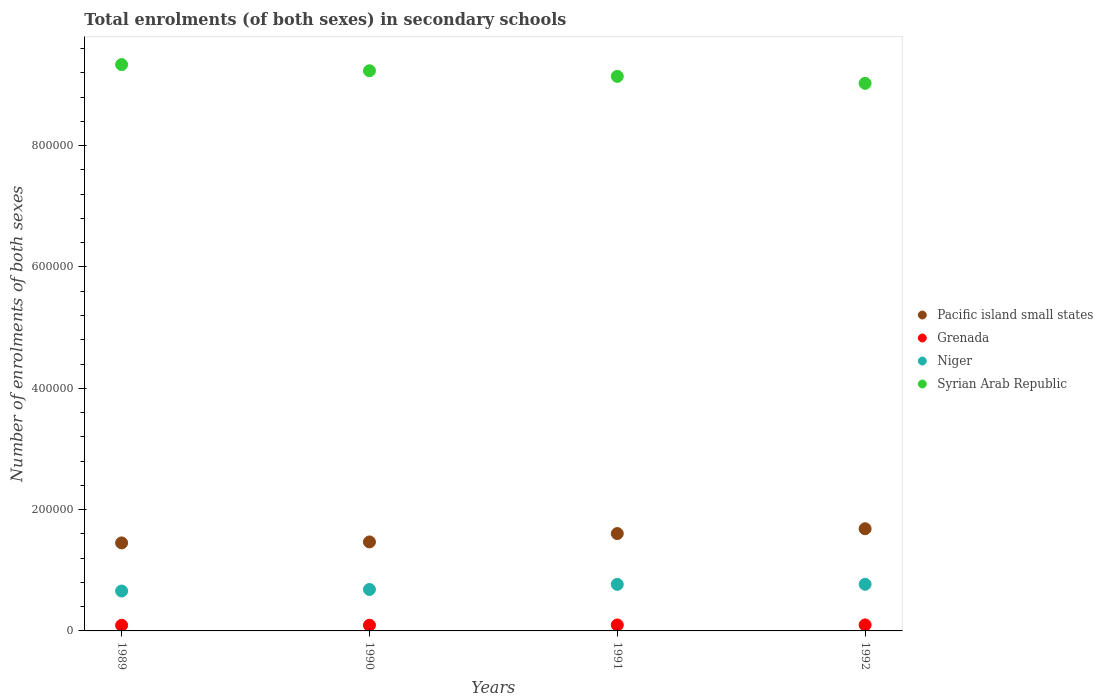Is the number of dotlines equal to the number of legend labels?
Your response must be concise. Yes. What is the number of enrolments in secondary schools in Niger in 1992?
Make the answer very short. 7.69e+04. Across all years, what is the maximum number of enrolments in secondary schools in Niger?
Ensure brevity in your answer.  7.69e+04. Across all years, what is the minimum number of enrolments in secondary schools in Niger?
Ensure brevity in your answer.  6.58e+04. In which year was the number of enrolments in secondary schools in Niger maximum?
Your answer should be compact. 1992. What is the total number of enrolments in secondary schools in Syrian Arab Republic in the graph?
Ensure brevity in your answer.  3.67e+06. What is the difference between the number of enrolments in secondary schools in Grenada in 1990 and that in 1991?
Offer a very short reply. -370. What is the difference between the number of enrolments in secondary schools in Grenada in 1992 and the number of enrolments in secondary schools in Syrian Arab Republic in 1990?
Give a very brief answer. -9.14e+05. What is the average number of enrolments in secondary schools in Grenada per year?
Provide a short and direct response. 9599.25. In the year 1992, what is the difference between the number of enrolments in secondary schools in Grenada and number of enrolments in secondary schools in Syrian Arab Republic?
Keep it short and to the point. -8.93e+05. What is the ratio of the number of enrolments in secondary schools in Pacific island small states in 1990 to that in 1991?
Provide a short and direct response. 0.91. What is the difference between the highest and the second highest number of enrolments in secondary schools in Syrian Arab Republic?
Offer a very short reply. 1.01e+04. What is the difference between the highest and the lowest number of enrolments in secondary schools in Syrian Arab Republic?
Your answer should be compact. 3.08e+04. Does the number of enrolments in secondary schools in Pacific island small states monotonically increase over the years?
Your answer should be very brief. Yes. Is the number of enrolments in secondary schools in Pacific island small states strictly less than the number of enrolments in secondary schools in Grenada over the years?
Your answer should be compact. No. How many dotlines are there?
Provide a succinct answer. 4. How many years are there in the graph?
Keep it short and to the point. 4. Are the values on the major ticks of Y-axis written in scientific E-notation?
Ensure brevity in your answer.  No. Does the graph contain grids?
Give a very brief answer. No. How many legend labels are there?
Your answer should be compact. 4. What is the title of the graph?
Offer a terse response. Total enrolments (of both sexes) in secondary schools. What is the label or title of the Y-axis?
Make the answer very short. Number of enrolments of both sexes. What is the Number of enrolments of both sexes of Pacific island small states in 1989?
Your answer should be compact. 1.45e+05. What is the Number of enrolments of both sexes in Grenada in 1989?
Give a very brief answer. 9319. What is the Number of enrolments of both sexes in Niger in 1989?
Provide a short and direct response. 6.58e+04. What is the Number of enrolments of both sexes of Syrian Arab Republic in 1989?
Ensure brevity in your answer.  9.34e+05. What is the Number of enrolments of both sexes of Pacific island small states in 1990?
Offer a very short reply. 1.47e+05. What is the Number of enrolments of both sexes of Grenada in 1990?
Your answer should be compact. 9406. What is the Number of enrolments of both sexes of Niger in 1990?
Provide a succinct answer. 6.84e+04. What is the Number of enrolments of both sexes of Syrian Arab Republic in 1990?
Offer a very short reply. 9.24e+05. What is the Number of enrolments of both sexes in Pacific island small states in 1991?
Provide a succinct answer. 1.61e+05. What is the Number of enrolments of both sexes in Grenada in 1991?
Ensure brevity in your answer.  9776. What is the Number of enrolments of both sexes in Niger in 1991?
Keep it short and to the point. 7.68e+04. What is the Number of enrolments of both sexes of Syrian Arab Republic in 1991?
Offer a terse response. 9.14e+05. What is the Number of enrolments of both sexes of Pacific island small states in 1992?
Provide a short and direct response. 1.68e+05. What is the Number of enrolments of both sexes of Grenada in 1992?
Offer a terse response. 9896. What is the Number of enrolments of both sexes of Niger in 1992?
Provide a short and direct response. 7.69e+04. What is the Number of enrolments of both sexes in Syrian Arab Republic in 1992?
Give a very brief answer. 9.03e+05. Across all years, what is the maximum Number of enrolments of both sexes of Pacific island small states?
Make the answer very short. 1.68e+05. Across all years, what is the maximum Number of enrolments of both sexes in Grenada?
Make the answer very short. 9896. Across all years, what is the maximum Number of enrolments of both sexes of Niger?
Give a very brief answer. 7.69e+04. Across all years, what is the maximum Number of enrolments of both sexes of Syrian Arab Republic?
Ensure brevity in your answer.  9.34e+05. Across all years, what is the minimum Number of enrolments of both sexes of Pacific island small states?
Your answer should be compact. 1.45e+05. Across all years, what is the minimum Number of enrolments of both sexes of Grenada?
Your response must be concise. 9319. Across all years, what is the minimum Number of enrolments of both sexes of Niger?
Provide a succinct answer. 6.58e+04. Across all years, what is the minimum Number of enrolments of both sexes in Syrian Arab Republic?
Your answer should be compact. 9.03e+05. What is the total Number of enrolments of both sexes of Pacific island small states in the graph?
Keep it short and to the point. 6.21e+05. What is the total Number of enrolments of both sexes of Grenada in the graph?
Offer a very short reply. 3.84e+04. What is the total Number of enrolments of both sexes of Niger in the graph?
Give a very brief answer. 2.88e+05. What is the total Number of enrolments of both sexes in Syrian Arab Republic in the graph?
Offer a terse response. 3.67e+06. What is the difference between the Number of enrolments of both sexes in Pacific island small states in 1989 and that in 1990?
Give a very brief answer. -1612.2. What is the difference between the Number of enrolments of both sexes of Grenada in 1989 and that in 1990?
Your answer should be compact. -87. What is the difference between the Number of enrolments of both sexes in Niger in 1989 and that in 1990?
Provide a short and direct response. -2536. What is the difference between the Number of enrolments of both sexes of Syrian Arab Republic in 1989 and that in 1990?
Your answer should be very brief. 1.01e+04. What is the difference between the Number of enrolments of both sexes of Pacific island small states in 1989 and that in 1991?
Provide a short and direct response. -1.54e+04. What is the difference between the Number of enrolments of both sexes of Grenada in 1989 and that in 1991?
Your answer should be very brief. -457. What is the difference between the Number of enrolments of both sexes in Niger in 1989 and that in 1991?
Your answer should be compact. -1.09e+04. What is the difference between the Number of enrolments of both sexes of Syrian Arab Republic in 1989 and that in 1991?
Give a very brief answer. 1.94e+04. What is the difference between the Number of enrolments of both sexes of Pacific island small states in 1989 and that in 1992?
Provide a succinct answer. -2.34e+04. What is the difference between the Number of enrolments of both sexes in Grenada in 1989 and that in 1992?
Your answer should be compact. -577. What is the difference between the Number of enrolments of both sexes in Niger in 1989 and that in 1992?
Your answer should be compact. -1.11e+04. What is the difference between the Number of enrolments of both sexes in Syrian Arab Republic in 1989 and that in 1992?
Your response must be concise. 3.08e+04. What is the difference between the Number of enrolments of both sexes in Pacific island small states in 1990 and that in 1991?
Offer a terse response. -1.38e+04. What is the difference between the Number of enrolments of both sexes in Grenada in 1990 and that in 1991?
Keep it short and to the point. -370. What is the difference between the Number of enrolments of both sexes in Niger in 1990 and that in 1991?
Offer a very short reply. -8406. What is the difference between the Number of enrolments of both sexes of Syrian Arab Republic in 1990 and that in 1991?
Provide a short and direct response. 9282. What is the difference between the Number of enrolments of both sexes in Pacific island small states in 1990 and that in 1992?
Offer a terse response. -2.17e+04. What is the difference between the Number of enrolments of both sexes in Grenada in 1990 and that in 1992?
Offer a very short reply. -490. What is the difference between the Number of enrolments of both sexes of Niger in 1990 and that in 1992?
Give a very brief answer. -8564. What is the difference between the Number of enrolments of both sexes in Syrian Arab Republic in 1990 and that in 1992?
Make the answer very short. 2.07e+04. What is the difference between the Number of enrolments of both sexes of Pacific island small states in 1991 and that in 1992?
Your answer should be compact. -7924.67. What is the difference between the Number of enrolments of both sexes of Grenada in 1991 and that in 1992?
Your answer should be very brief. -120. What is the difference between the Number of enrolments of both sexes of Niger in 1991 and that in 1992?
Provide a succinct answer. -158. What is the difference between the Number of enrolments of both sexes of Syrian Arab Republic in 1991 and that in 1992?
Make the answer very short. 1.14e+04. What is the difference between the Number of enrolments of both sexes in Pacific island small states in 1989 and the Number of enrolments of both sexes in Grenada in 1990?
Your answer should be compact. 1.36e+05. What is the difference between the Number of enrolments of both sexes of Pacific island small states in 1989 and the Number of enrolments of both sexes of Niger in 1990?
Your answer should be very brief. 7.67e+04. What is the difference between the Number of enrolments of both sexes of Pacific island small states in 1989 and the Number of enrolments of both sexes of Syrian Arab Republic in 1990?
Provide a succinct answer. -7.78e+05. What is the difference between the Number of enrolments of both sexes of Grenada in 1989 and the Number of enrolments of both sexes of Niger in 1990?
Give a very brief answer. -5.90e+04. What is the difference between the Number of enrolments of both sexes in Grenada in 1989 and the Number of enrolments of both sexes in Syrian Arab Republic in 1990?
Provide a succinct answer. -9.14e+05. What is the difference between the Number of enrolments of both sexes of Niger in 1989 and the Number of enrolments of both sexes of Syrian Arab Republic in 1990?
Offer a terse response. -8.58e+05. What is the difference between the Number of enrolments of both sexes in Pacific island small states in 1989 and the Number of enrolments of both sexes in Grenada in 1991?
Provide a short and direct response. 1.35e+05. What is the difference between the Number of enrolments of both sexes in Pacific island small states in 1989 and the Number of enrolments of both sexes in Niger in 1991?
Keep it short and to the point. 6.83e+04. What is the difference between the Number of enrolments of both sexes of Pacific island small states in 1989 and the Number of enrolments of both sexes of Syrian Arab Republic in 1991?
Keep it short and to the point. -7.69e+05. What is the difference between the Number of enrolments of both sexes in Grenada in 1989 and the Number of enrolments of both sexes in Niger in 1991?
Your answer should be very brief. -6.74e+04. What is the difference between the Number of enrolments of both sexes in Grenada in 1989 and the Number of enrolments of both sexes in Syrian Arab Republic in 1991?
Your answer should be compact. -9.05e+05. What is the difference between the Number of enrolments of both sexes of Niger in 1989 and the Number of enrolments of both sexes of Syrian Arab Republic in 1991?
Keep it short and to the point. -8.48e+05. What is the difference between the Number of enrolments of both sexes of Pacific island small states in 1989 and the Number of enrolments of both sexes of Grenada in 1992?
Give a very brief answer. 1.35e+05. What is the difference between the Number of enrolments of both sexes of Pacific island small states in 1989 and the Number of enrolments of both sexes of Niger in 1992?
Give a very brief answer. 6.82e+04. What is the difference between the Number of enrolments of both sexes of Pacific island small states in 1989 and the Number of enrolments of both sexes of Syrian Arab Republic in 1992?
Your response must be concise. -7.58e+05. What is the difference between the Number of enrolments of both sexes in Grenada in 1989 and the Number of enrolments of both sexes in Niger in 1992?
Give a very brief answer. -6.76e+04. What is the difference between the Number of enrolments of both sexes in Grenada in 1989 and the Number of enrolments of both sexes in Syrian Arab Republic in 1992?
Give a very brief answer. -8.94e+05. What is the difference between the Number of enrolments of both sexes of Niger in 1989 and the Number of enrolments of both sexes of Syrian Arab Republic in 1992?
Your answer should be compact. -8.37e+05. What is the difference between the Number of enrolments of both sexes of Pacific island small states in 1990 and the Number of enrolments of both sexes of Grenada in 1991?
Offer a very short reply. 1.37e+05. What is the difference between the Number of enrolments of both sexes in Pacific island small states in 1990 and the Number of enrolments of both sexes in Niger in 1991?
Offer a very short reply. 7.00e+04. What is the difference between the Number of enrolments of both sexes in Pacific island small states in 1990 and the Number of enrolments of both sexes in Syrian Arab Republic in 1991?
Keep it short and to the point. -7.68e+05. What is the difference between the Number of enrolments of both sexes in Grenada in 1990 and the Number of enrolments of both sexes in Niger in 1991?
Make the answer very short. -6.74e+04. What is the difference between the Number of enrolments of both sexes in Grenada in 1990 and the Number of enrolments of both sexes in Syrian Arab Republic in 1991?
Provide a succinct answer. -9.05e+05. What is the difference between the Number of enrolments of both sexes in Niger in 1990 and the Number of enrolments of both sexes in Syrian Arab Republic in 1991?
Offer a very short reply. -8.46e+05. What is the difference between the Number of enrolments of both sexes in Pacific island small states in 1990 and the Number of enrolments of both sexes in Grenada in 1992?
Ensure brevity in your answer.  1.37e+05. What is the difference between the Number of enrolments of both sexes in Pacific island small states in 1990 and the Number of enrolments of both sexes in Niger in 1992?
Ensure brevity in your answer.  6.98e+04. What is the difference between the Number of enrolments of both sexes in Pacific island small states in 1990 and the Number of enrolments of both sexes in Syrian Arab Republic in 1992?
Offer a terse response. -7.56e+05. What is the difference between the Number of enrolments of both sexes in Grenada in 1990 and the Number of enrolments of both sexes in Niger in 1992?
Make the answer very short. -6.75e+04. What is the difference between the Number of enrolments of both sexes of Grenada in 1990 and the Number of enrolments of both sexes of Syrian Arab Republic in 1992?
Offer a very short reply. -8.93e+05. What is the difference between the Number of enrolments of both sexes in Niger in 1990 and the Number of enrolments of both sexes in Syrian Arab Republic in 1992?
Provide a short and direct response. -8.34e+05. What is the difference between the Number of enrolments of both sexes of Pacific island small states in 1991 and the Number of enrolments of both sexes of Grenada in 1992?
Provide a short and direct response. 1.51e+05. What is the difference between the Number of enrolments of both sexes in Pacific island small states in 1991 and the Number of enrolments of both sexes in Niger in 1992?
Ensure brevity in your answer.  8.36e+04. What is the difference between the Number of enrolments of both sexes in Pacific island small states in 1991 and the Number of enrolments of both sexes in Syrian Arab Republic in 1992?
Ensure brevity in your answer.  -7.42e+05. What is the difference between the Number of enrolments of both sexes of Grenada in 1991 and the Number of enrolments of both sexes of Niger in 1992?
Ensure brevity in your answer.  -6.71e+04. What is the difference between the Number of enrolments of both sexes of Grenada in 1991 and the Number of enrolments of both sexes of Syrian Arab Republic in 1992?
Give a very brief answer. -8.93e+05. What is the difference between the Number of enrolments of both sexes of Niger in 1991 and the Number of enrolments of both sexes of Syrian Arab Republic in 1992?
Your response must be concise. -8.26e+05. What is the average Number of enrolments of both sexes of Pacific island small states per year?
Offer a terse response. 1.55e+05. What is the average Number of enrolments of both sexes in Grenada per year?
Make the answer very short. 9599.25. What is the average Number of enrolments of both sexes in Niger per year?
Provide a succinct answer. 7.20e+04. What is the average Number of enrolments of both sexes of Syrian Arab Republic per year?
Provide a succinct answer. 9.19e+05. In the year 1989, what is the difference between the Number of enrolments of both sexes of Pacific island small states and Number of enrolments of both sexes of Grenada?
Your response must be concise. 1.36e+05. In the year 1989, what is the difference between the Number of enrolments of both sexes of Pacific island small states and Number of enrolments of both sexes of Niger?
Keep it short and to the point. 7.93e+04. In the year 1989, what is the difference between the Number of enrolments of both sexes of Pacific island small states and Number of enrolments of both sexes of Syrian Arab Republic?
Offer a very short reply. -7.89e+05. In the year 1989, what is the difference between the Number of enrolments of both sexes in Grenada and Number of enrolments of both sexes in Niger?
Offer a very short reply. -5.65e+04. In the year 1989, what is the difference between the Number of enrolments of both sexes in Grenada and Number of enrolments of both sexes in Syrian Arab Republic?
Ensure brevity in your answer.  -9.24e+05. In the year 1989, what is the difference between the Number of enrolments of both sexes of Niger and Number of enrolments of both sexes of Syrian Arab Republic?
Keep it short and to the point. -8.68e+05. In the year 1990, what is the difference between the Number of enrolments of both sexes in Pacific island small states and Number of enrolments of both sexes in Grenada?
Offer a terse response. 1.37e+05. In the year 1990, what is the difference between the Number of enrolments of both sexes in Pacific island small states and Number of enrolments of both sexes in Niger?
Keep it short and to the point. 7.84e+04. In the year 1990, what is the difference between the Number of enrolments of both sexes of Pacific island small states and Number of enrolments of both sexes of Syrian Arab Republic?
Keep it short and to the point. -7.77e+05. In the year 1990, what is the difference between the Number of enrolments of both sexes in Grenada and Number of enrolments of both sexes in Niger?
Your answer should be very brief. -5.89e+04. In the year 1990, what is the difference between the Number of enrolments of both sexes in Grenada and Number of enrolments of both sexes in Syrian Arab Republic?
Provide a short and direct response. -9.14e+05. In the year 1990, what is the difference between the Number of enrolments of both sexes of Niger and Number of enrolments of both sexes of Syrian Arab Republic?
Your answer should be compact. -8.55e+05. In the year 1991, what is the difference between the Number of enrolments of both sexes in Pacific island small states and Number of enrolments of both sexes in Grenada?
Your answer should be compact. 1.51e+05. In the year 1991, what is the difference between the Number of enrolments of both sexes in Pacific island small states and Number of enrolments of both sexes in Niger?
Provide a short and direct response. 8.38e+04. In the year 1991, what is the difference between the Number of enrolments of both sexes of Pacific island small states and Number of enrolments of both sexes of Syrian Arab Republic?
Your answer should be compact. -7.54e+05. In the year 1991, what is the difference between the Number of enrolments of both sexes of Grenada and Number of enrolments of both sexes of Niger?
Offer a very short reply. -6.70e+04. In the year 1991, what is the difference between the Number of enrolments of both sexes in Grenada and Number of enrolments of both sexes in Syrian Arab Republic?
Your answer should be very brief. -9.04e+05. In the year 1991, what is the difference between the Number of enrolments of both sexes of Niger and Number of enrolments of both sexes of Syrian Arab Republic?
Offer a very short reply. -8.37e+05. In the year 1992, what is the difference between the Number of enrolments of both sexes of Pacific island small states and Number of enrolments of both sexes of Grenada?
Offer a very short reply. 1.59e+05. In the year 1992, what is the difference between the Number of enrolments of both sexes of Pacific island small states and Number of enrolments of both sexes of Niger?
Your answer should be very brief. 9.15e+04. In the year 1992, what is the difference between the Number of enrolments of both sexes of Pacific island small states and Number of enrolments of both sexes of Syrian Arab Republic?
Give a very brief answer. -7.34e+05. In the year 1992, what is the difference between the Number of enrolments of both sexes of Grenada and Number of enrolments of both sexes of Niger?
Your answer should be very brief. -6.70e+04. In the year 1992, what is the difference between the Number of enrolments of both sexes of Grenada and Number of enrolments of both sexes of Syrian Arab Republic?
Give a very brief answer. -8.93e+05. In the year 1992, what is the difference between the Number of enrolments of both sexes of Niger and Number of enrolments of both sexes of Syrian Arab Republic?
Offer a terse response. -8.26e+05. What is the ratio of the Number of enrolments of both sexes in Pacific island small states in 1989 to that in 1990?
Give a very brief answer. 0.99. What is the ratio of the Number of enrolments of both sexes in Niger in 1989 to that in 1990?
Make the answer very short. 0.96. What is the ratio of the Number of enrolments of both sexes of Pacific island small states in 1989 to that in 1991?
Your answer should be very brief. 0.9. What is the ratio of the Number of enrolments of both sexes in Grenada in 1989 to that in 1991?
Offer a terse response. 0.95. What is the ratio of the Number of enrolments of both sexes in Niger in 1989 to that in 1991?
Your answer should be very brief. 0.86. What is the ratio of the Number of enrolments of both sexes of Syrian Arab Republic in 1989 to that in 1991?
Your answer should be very brief. 1.02. What is the ratio of the Number of enrolments of both sexes of Pacific island small states in 1989 to that in 1992?
Provide a short and direct response. 0.86. What is the ratio of the Number of enrolments of both sexes of Grenada in 1989 to that in 1992?
Your answer should be very brief. 0.94. What is the ratio of the Number of enrolments of both sexes in Niger in 1989 to that in 1992?
Provide a succinct answer. 0.86. What is the ratio of the Number of enrolments of both sexes of Syrian Arab Republic in 1989 to that in 1992?
Your response must be concise. 1.03. What is the ratio of the Number of enrolments of both sexes in Pacific island small states in 1990 to that in 1991?
Your response must be concise. 0.91. What is the ratio of the Number of enrolments of both sexes of Grenada in 1990 to that in 1991?
Your response must be concise. 0.96. What is the ratio of the Number of enrolments of both sexes in Niger in 1990 to that in 1991?
Offer a very short reply. 0.89. What is the ratio of the Number of enrolments of both sexes in Syrian Arab Republic in 1990 to that in 1991?
Offer a very short reply. 1.01. What is the ratio of the Number of enrolments of both sexes in Pacific island small states in 1990 to that in 1992?
Your response must be concise. 0.87. What is the ratio of the Number of enrolments of both sexes in Grenada in 1990 to that in 1992?
Give a very brief answer. 0.95. What is the ratio of the Number of enrolments of both sexes in Niger in 1990 to that in 1992?
Give a very brief answer. 0.89. What is the ratio of the Number of enrolments of both sexes of Syrian Arab Republic in 1990 to that in 1992?
Keep it short and to the point. 1.02. What is the ratio of the Number of enrolments of both sexes in Pacific island small states in 1991 to that in 1992?
Keep it short and to the point. 0.95. What is the ratio of the Number of enrolments of both sexes of Grenada in 1991 to that in 1992?
Make the answer very short. 0.99. What is the ratio of the Number of enrolments of both sexes in Syrian Arab Republic in 1991 to that in 1992?
Offer a terse response. 1.01. What is the difference between the highest and the second highest Number of enrolments of both sexes in Pacific island small states?
Provide a short and direct response. 7924.67. What is the difference between the highest and the second highest Number of enrolments of both sexes of Grenada?
Offer a terse response. 120. What is the difference between the highest and the second highest Number of enrolments of both sexes of Niger?
Provide a succinct answer. 158. What is the difference between the highest and the second highest Number of enrolments of both sexes of Syrian Arab Republic?
Provide a short and direct response. 1.01e+04. What is the difference between the highest and the lowest Number of enrolments of both sexes in Pacific island small states?
Provide a succinct answer. 2.34e+04. What is the difference between the highest and the lowest Number of enrolments of both sexes of Grenada?
Give a very brief answer. 577. What is the difference between the highest and the lowest Number of enrolments of both sexes of Niger?
Provide a succinct answer. 1.11e+04. What is the difference between the highest and the lowest Number of enrolments of both sexes in Syrian Arab Republic?
Your response must be concise. 3.08e+04. 